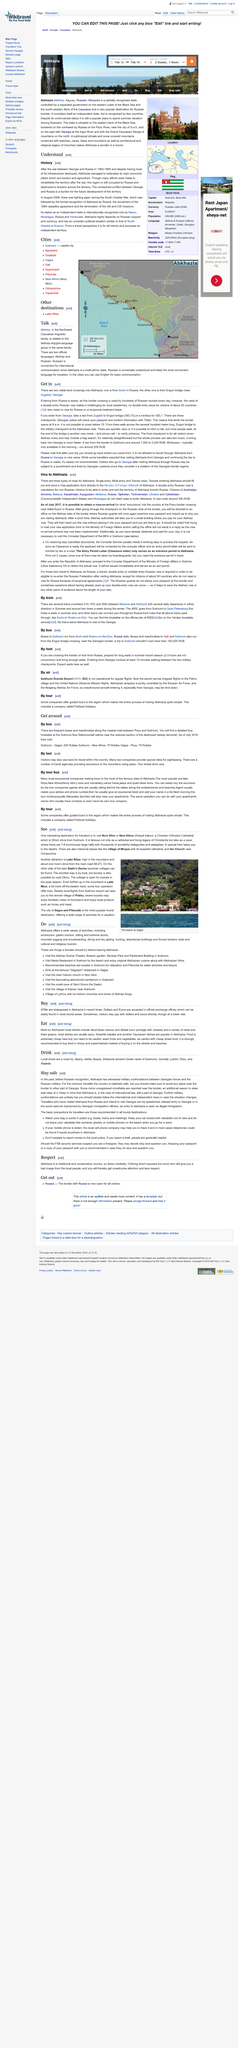Give some essential details in this illustration. Stalin's Dacha, the summer cottage of the former Soviet leader Joseph Stalin, can be found on Lake Ritsa. It is advisable to exercise caution when traveling to Abkhazia, particularly in areas near the border between Russia and Georgia, to ensure your safety. There are reported to be minor unregistered minefields near the border between Georgia and Russia, with some present in close proximity to the border. It is a 20-minute drive from Sukhumi to Novi Afon or New Athos the Christian Orthodox Cathedral. Lake Ritsa is located in the mountains and can be accessed by driving about one hour from the main road (M-27). 